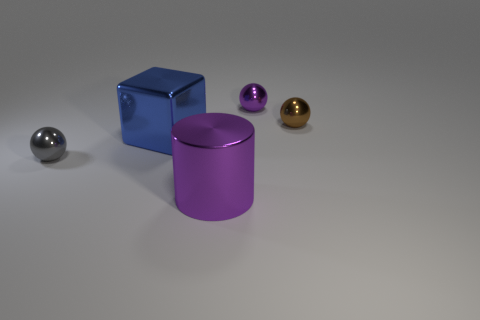Is the size of the blue cube the same as the gray object?
Provide a short and direct response. No. What number of other things are there of the same size as the cube?
Provide a succinct answer. 1. Do the block and the cylinder have the same color?
Offer a terse response. No. The big metallic thing behind the tiny ball to the left of the purple shiny object that is behind the tiny gray sphere is what shape?
Your answer should be compact. Cube. What number of objects are either large objects on the left side of the large metallic cylinder or metallic things on the right side of the purple cylinder?
Your answer should be compact. 3. How big is the purple object in front of the large metal object behind the cylinder?
Your response must be concise. Large. Does the metal object that is behind the small brown metallic sphere have the same color as the cylinder?
Provide a short and direct response. Yes. Are there any purple objects of the same shape as the tiny gray shiny thing?
Provide a succinct answer. Yes. What is the color of the metal thing that is the same size as the cylinder?
Your response must be concise. Blue. What size is the metallic sphere that is to the right of the small purple shiny ball?
Offer a very short reply. Small. 